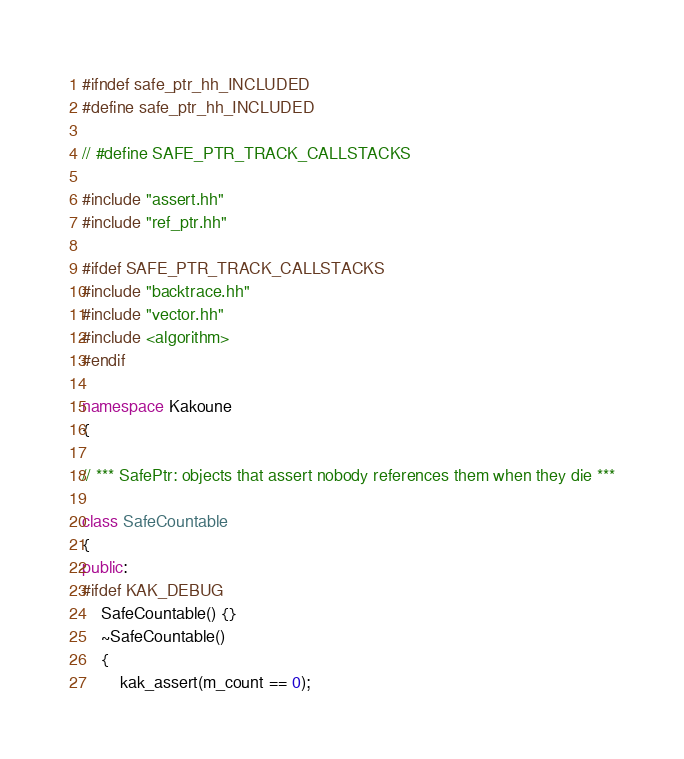<code> <loc_0><loc_0><loc_500><loc_500><_C++_>#ifndef safe_ptr_hh_INCLUDED
#define safe_ptr_hh_INCLUDED

// #define SAFE_PTR_TRACK_CALLSTACKS

#include "assert.hh"
#include "ref_ptr.hh"

#ifdef SAFE_PTR_TRACK_CALLSTACKS
#include "backtrace.hh"
#include "vector.hh"
#include <algorithm>
#endif

namespace Kakoune
{

// *** SafePtr: objects that assert nobody references them when they die ***

class SafeCountable
{
public:
#ifdef KAK_DEBUG
    SafeCountable() {}
    ~SafeCountable()
    {
        kak_assert(m_count == 0);</code> 